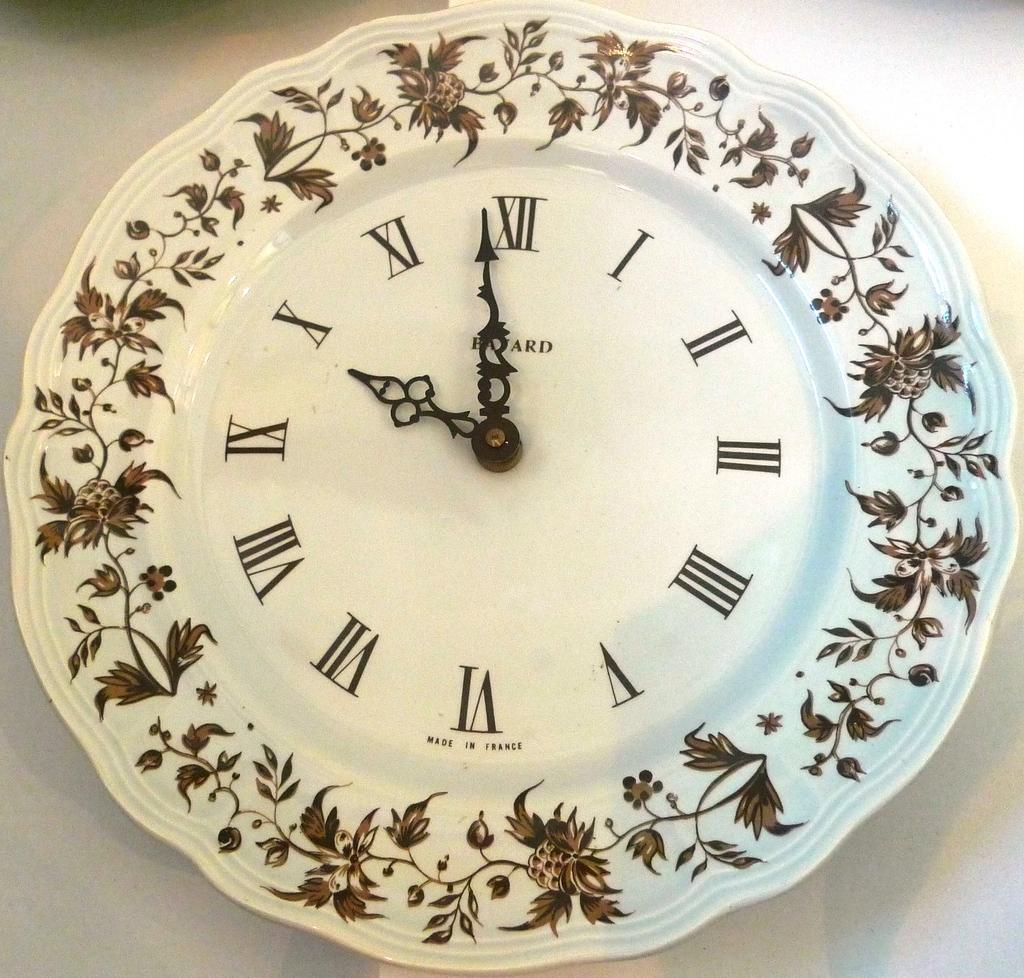<image>
Share a concise interpretation of the image provided. a clock painted on a plate that says 'balard' 